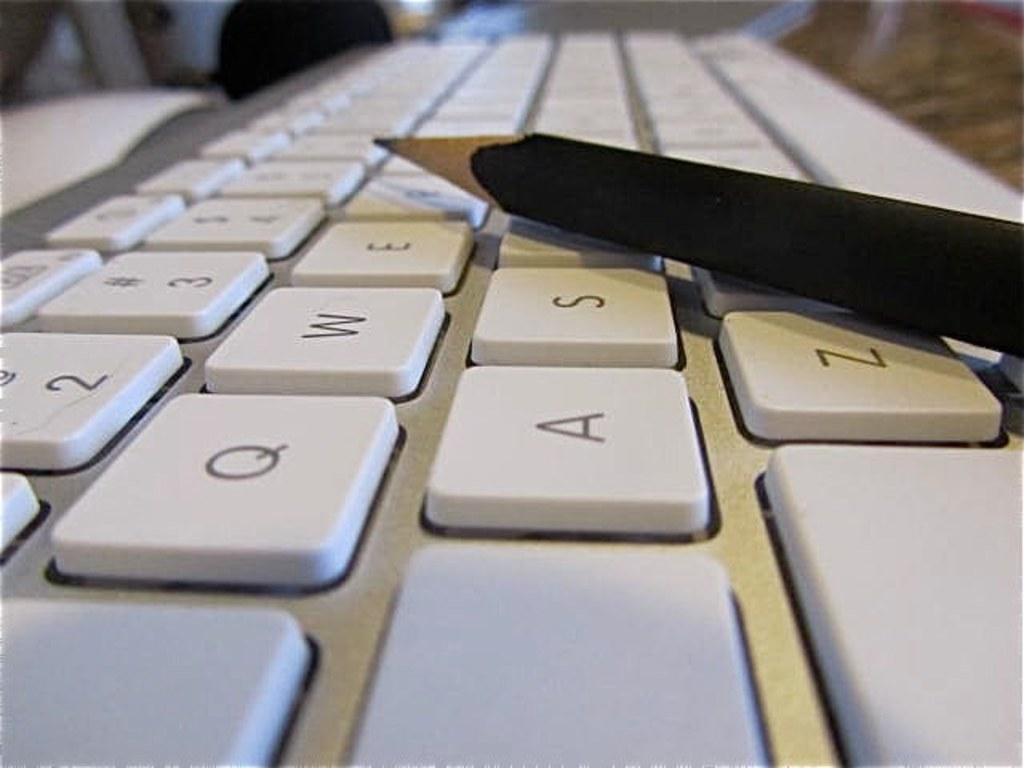<image>
Give a short and clear explanation of the subsequent image. A keyboard has a pencil on top of it, which is next to the letters E, S, and Z. 